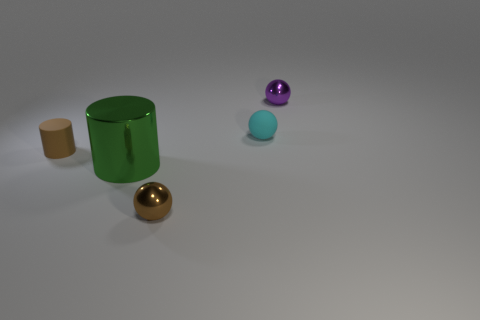Add 2 cyan matte cubes. How many objects exist? 7 Subtract 1 cylinders. How many cylinders are left? 1 Subtract all cyan rubber balls. How many balls are left? 2 Subtract all balls. How many objects are left? 2 Add 4 green metal cylinders. How many green metal cylinders are left? 5 Add 5 large metallic cylinders. How many large metallic cylinders exist? 6 Subtract all brown cylinders. How many cylinders are left? 1 Subtract 0 purple cylinders. How many objects are left? 5 Subtract all yellow cylinders. Subtract all gray cubes. How many cylinders are left? 2 Subtract all green cylinders. How many purple spheres are left? 1 